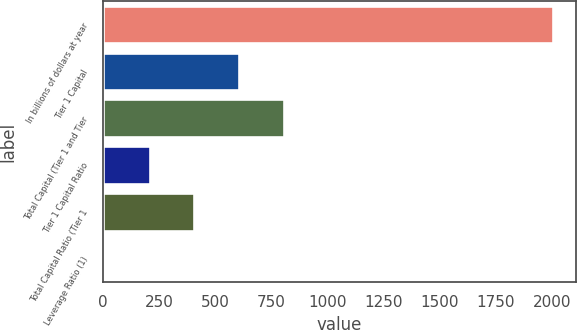Convert chart to OTSL. <chart><loc_0><loc_0><loc_500><loc_500><bar_chart><fcel>In billions of dollars at year<fcel>Tier 1 Capital<fcel>Total Capital (Tier 1 and Tier<fcel>Tier 1 Capital Ratio<fcel>Total Capital Ratio (Tier 1<fcel>Leverage Ratio (1)<nl><fcel>2007<fcel>606.76<fcel>806.79<fcel>206.69<fcel>406.73<fcel>6.65<nl></chart> 